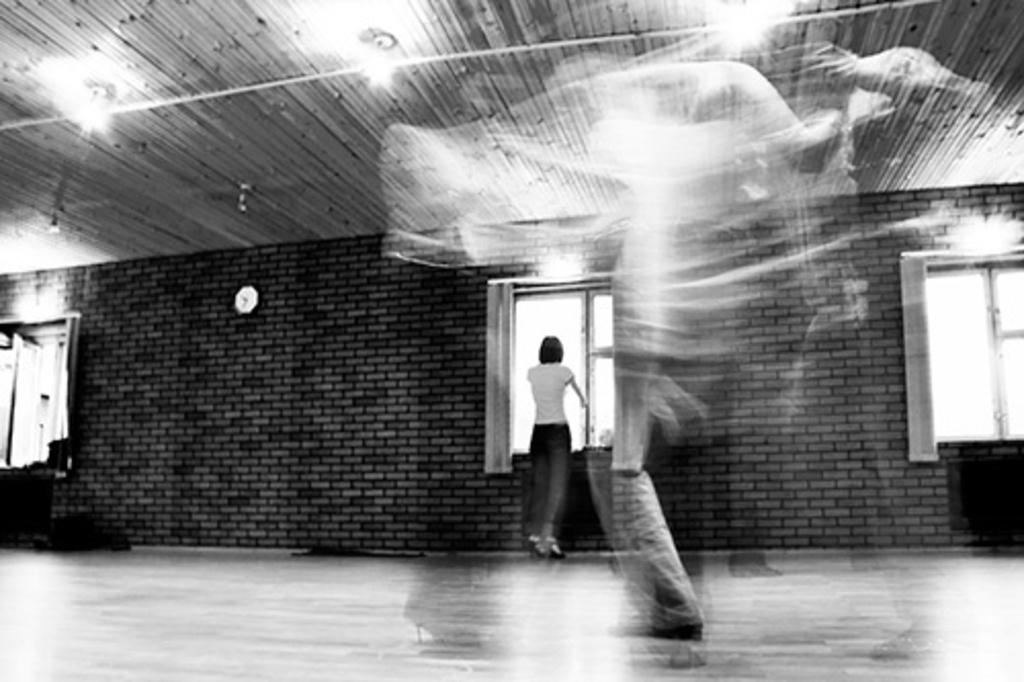What is the main subject in the image? There is a woman standing in the image. What can be seen in the background of the image? There are windows in the image. What is hanging on the wall in the image? There is a clock on the wall in the image. What type of lighting is present in the image? There are lights on the ceiling in the image. What is the color scheme of the image? The image is black and white in color. Can you see the seashore in the image? No, there is no seashore present in the image. 